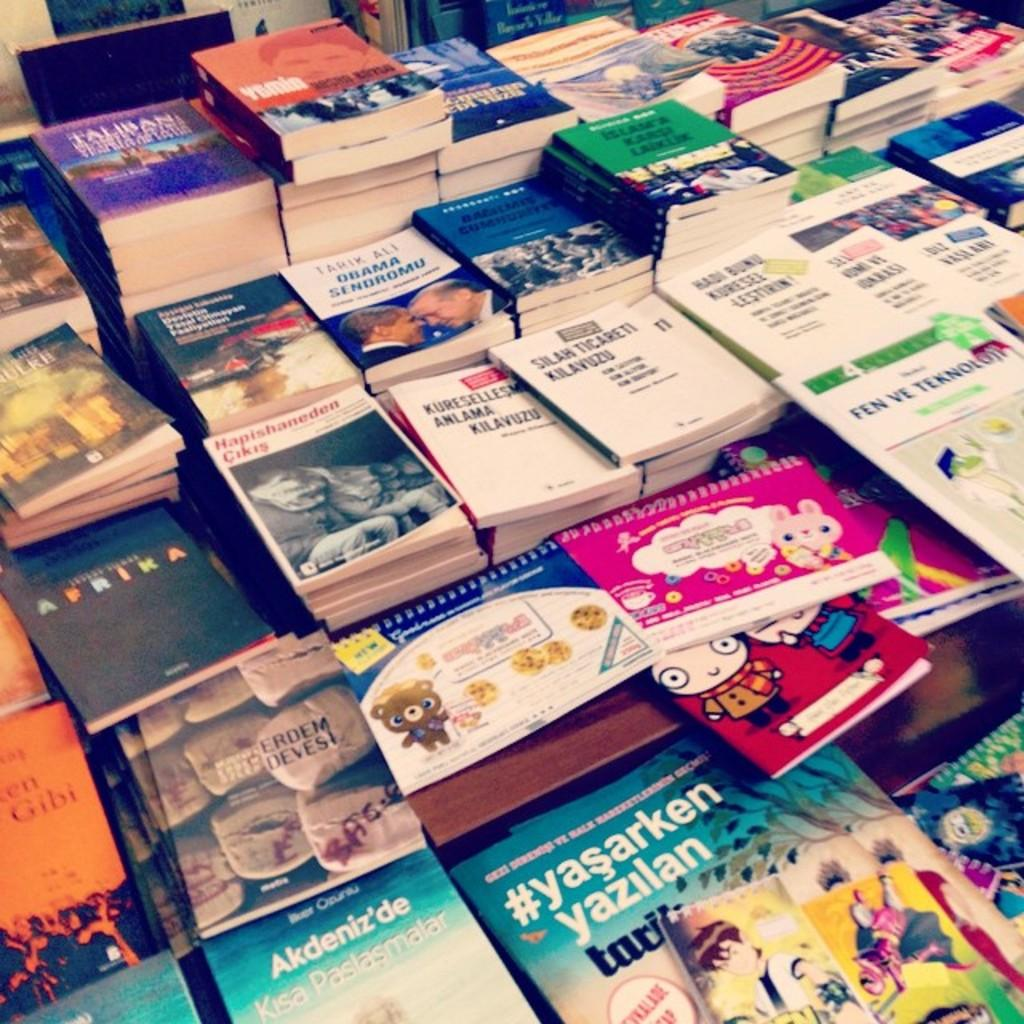Where was the image taken? The image is taken indoors. What can be seen on the table in the middle of the image? There are many books on a table in the middle of the image. What is the position of the chair in the image? There is an empty chair at the top of the image. What page of the book is the person reading in the image? There is no person reading a book in the image, so it is not possible to determine which page they might be on. 